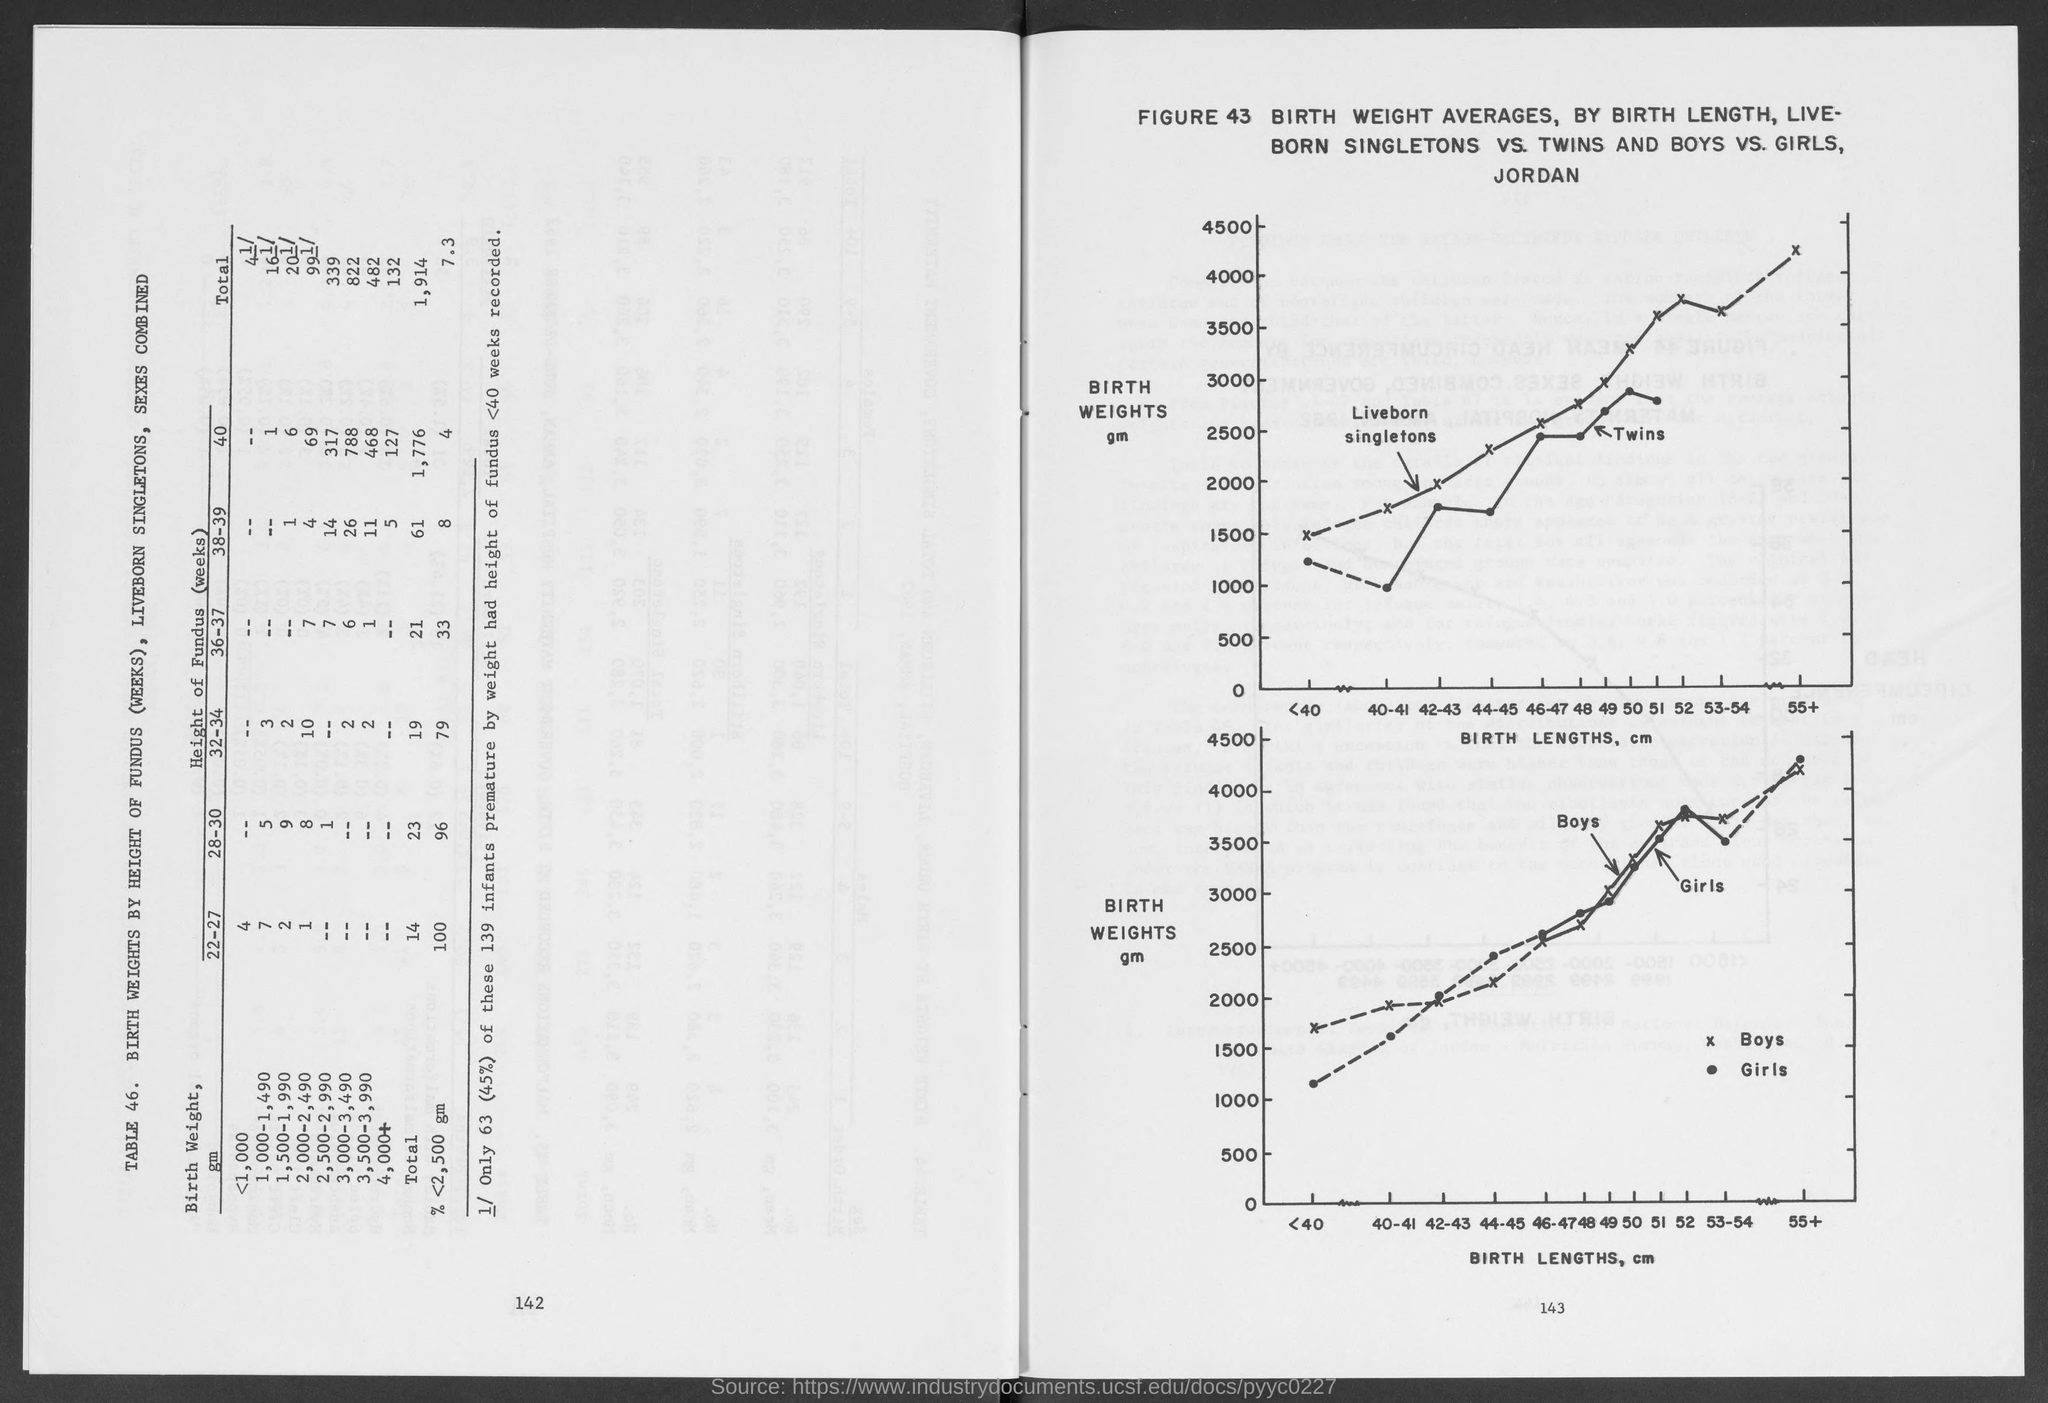What is plotted in the x-axis of both graph?
Make the answer very short. Birth Lengths, cm. What is plotted in the y-axis of both graph?
Give a very brief answer. Birth weights. 